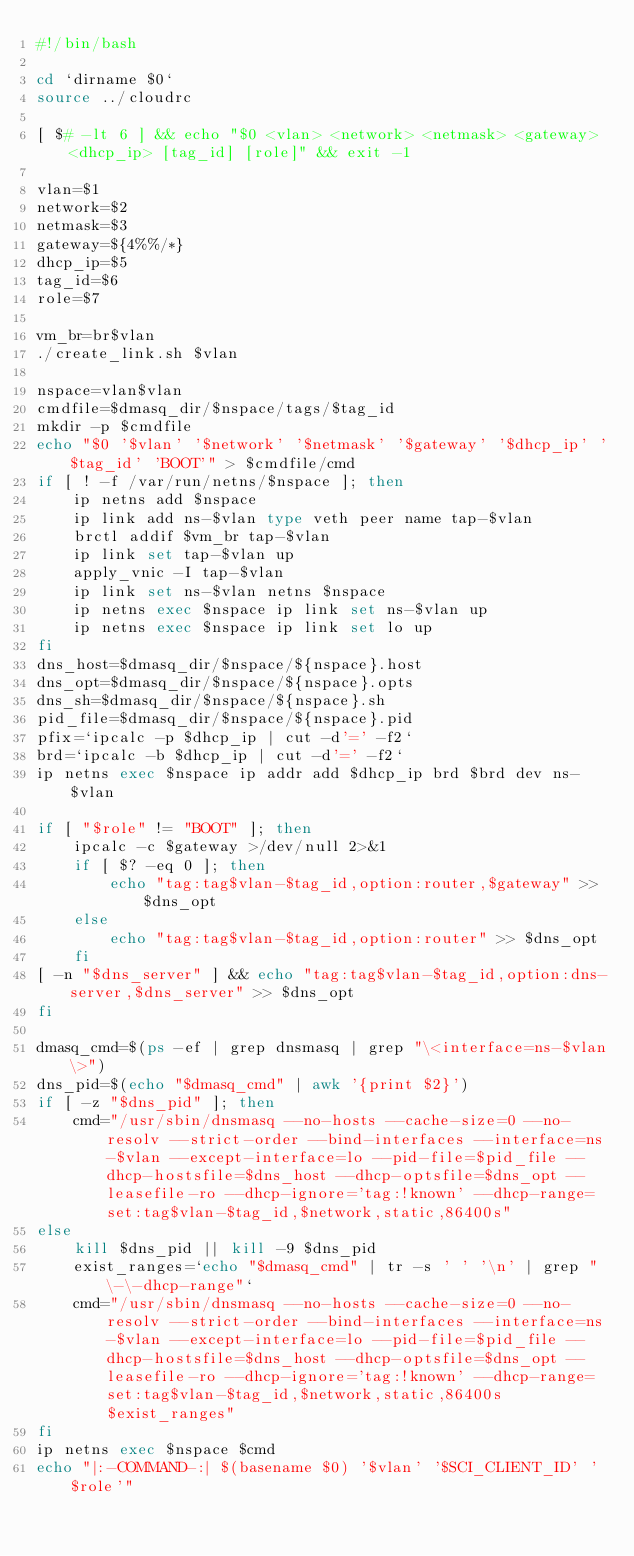<code> <loc_0><loc_0><loc_500><loc_500><_Bash_>#!/bin/bash

cd `dirname $0`
source ../cloudrc

[ $# -lt 6 ] && echo "$0 <vlan> <network> <netmask> <gateway> <dhcp_ip> [tag_id] [role]" && exit -1

vlan=$1
network=$2
netmask=$3
gateway=${4%%/*}
dhcp_ip=$5
tag_id=$6
role=$7

vm_br=br$vlan
./create_link.sh $vlan

nspace=vlan$vlan
cmdfile=$dmasq_dir/$nspace/tags/$tag_id
mkdir -p $cmdfile
echo "$0 '$vlan' '$network' '$netmask' '$gateway' '$dhcp_ip' '$tag_id' 'BOOT'" > $cmdfile/cmd
if [ ! -f /var/run/netns/$nspace ]; then
    ip netns add $nspace
    ip link add ns-$vlan type veth peer name tap-$vlan
    brctl addif $vm_br tap-$vlan
    ip link set tap-$vlan up
    apply_vnic -I tap-$vlan
    ip link set ns-$vlan netns $nspace
    ip netns exec $nspace ip link set ns-$vlan up
    ip netns exec $nspace ip link set lo up
fi
dns_host=$dmasq_dir/$nspace/${nspace}.host
dns_opt=$dmasq_dir/$nspace/${nspace}.opts
dns_sh=$dmasq_dir/$nspace/${nspace}.sh
pid_file=$dmasq_dir/$nspace/${nspace}.pid
pfix=`ipcalc -p $dhcp_ip | cut -d'=' -f2`
brd=`ipcalc -b $dhcp_ip | cut -d'=' -f2`
ip netns exec $nspace ip addr add $dhcp_ip brd $brd dev ns-$vlan

if [ "$role" != "BOOT" ]; then
    ipcalc -c $gateway >/dev/null 2>&1
    if [ $? -eq 0 ]; then
        echo "tag:tag$vlan-$tag_id,option:router,$gateway" >> $dns_opt
    else
        echo "tag:tag$vlan-$tag_id,option:router" >> $dns_opt
    fi
[ -n "$dns_server" ] && echo "tag:tag$vlan-$tag_id,option:dns-server,$dns_server" >> $dns_opt
fi

dmasq_cmd=$(ps -ef | grep dnsmasq | grep "\<interface=ns-$vlan\>")
dns_pid=$(echo "$dmasq_cmd" | awk '{print $2}')
if [ -z "$dns_pid" ]; then
    cmd="/usr/sbin/dnsmasq --no-hosts --cache-size=0 --no-resolv --strict-order --bind-interfaces --interface=ns-$vlan --except-interface=lo --pid-file=$pid_file --dhcp-hostsfile=$dns_host --dhcp-optsfile=$dns_opt --leasefile-ro --dhcp-ignore='tag:!known' --dhcp-range=set:tag$vlan-$tag_id,$network,static,86400s"
else
    kill $dns_pid || kill -9 $dns_pid
    exist_ranges=`echo "$dmasq_cmd" | tr -s ' ' '\n' | grep "\-\-dhcp-range"`
    cmd="/usr/sbin/dnsmasq --no-hosts --cache-size=0 --no-resolv --strict-order --bind-interfaces --interface=ns-$vlan --except-interface=lo --pid-file=$pid_file --dhcp-hostsfile=$dns_host --dhcp-optsfile=$dns_opt --leasefile-ro --dhcp-ignore='tag:!known' --dhcp-range=set:tag$vlan-$tag_id,$network,static,86400s $exist_ranges"
fi
ip netns exec $nspace $cmd
echo "|:-COMMAND-:| $(basename $0) '$vlan' '$SCI_CLIENT_ID' '$role'"
</code> 